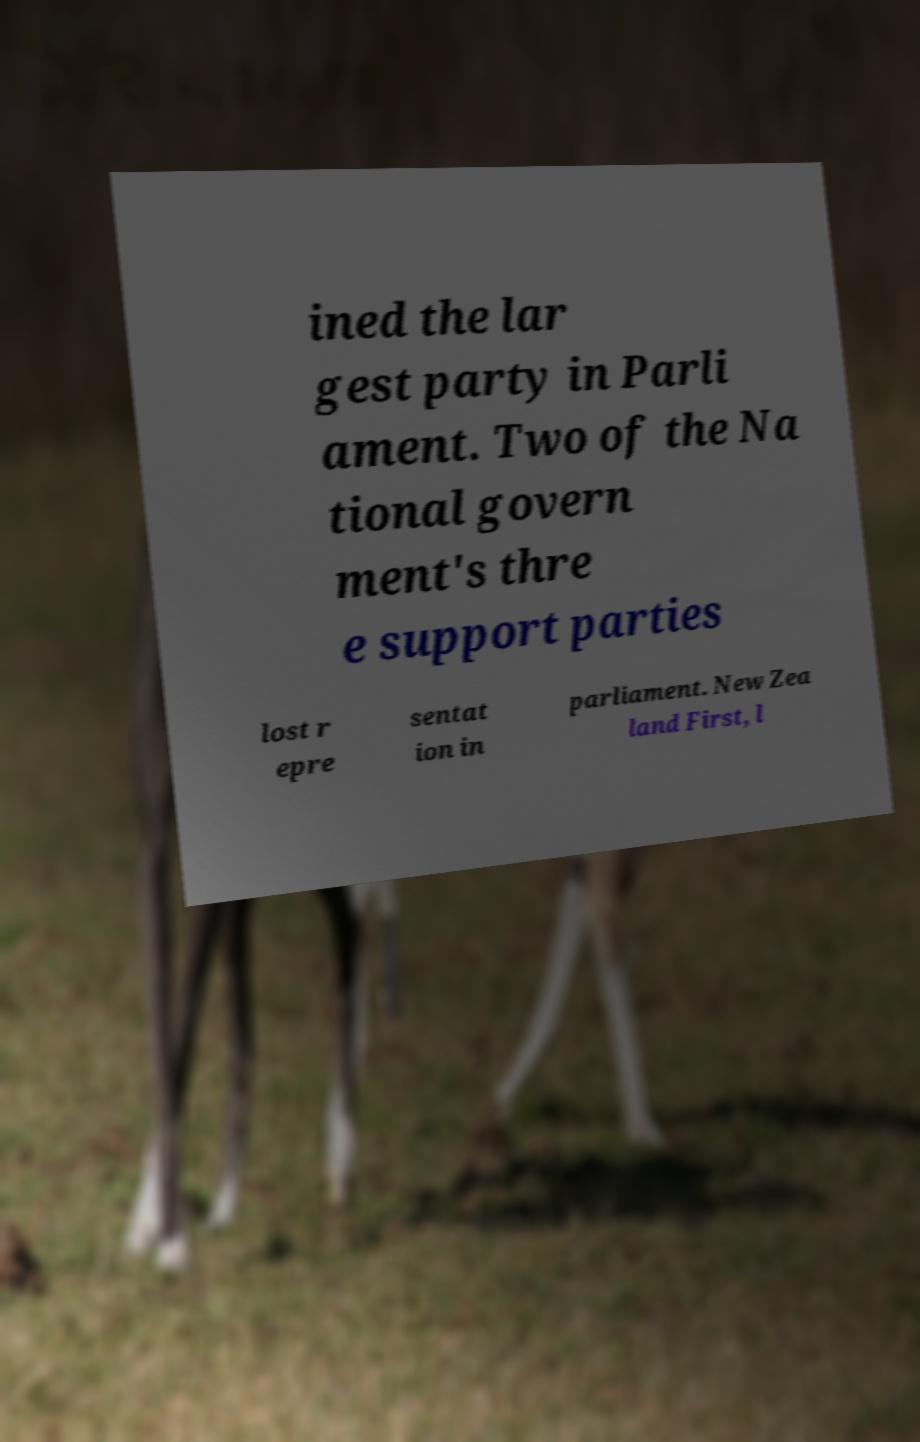Can you read and provide the text displayed in the image?This photo seems to have some interesting text. Can you extract and type it out for me? ined the lar gest party in Parli ament. Two of the Na tional govern ment's thre e support parties lost r epre sentat ion in parliament. New Zea land First, l 